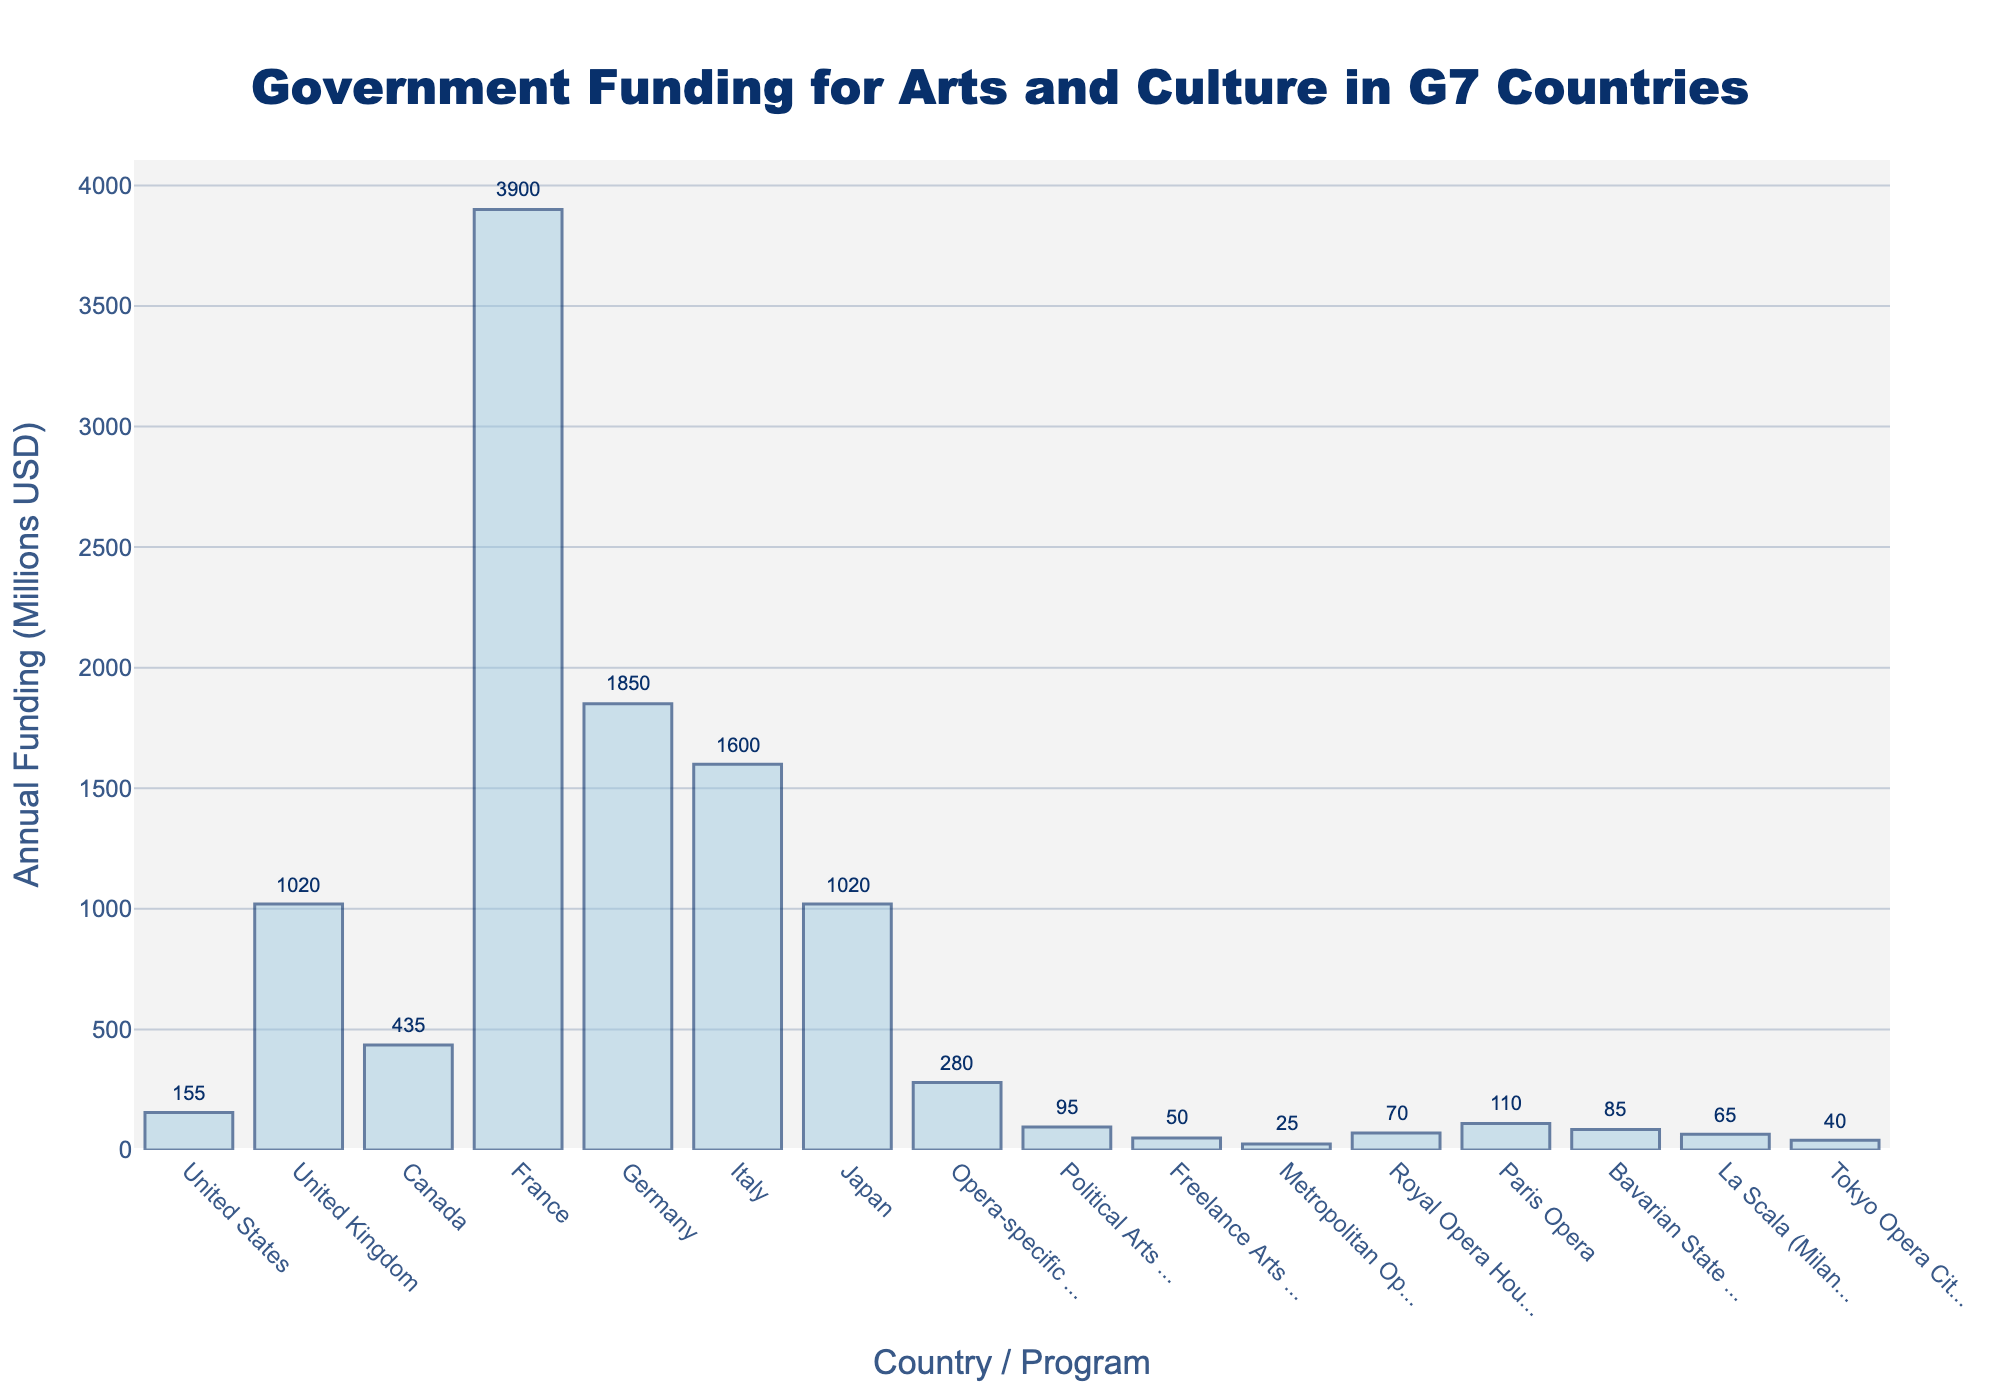What is the total annual funding for arts and culture in France and Germany? To get the total annual funding for France and Germany, sum the individual funding amounts for these two countries. France has $3900 million and Germany has $1850 million. So, the total is $3900 million + $1850 million = $5750 million.
Answer: $5750 million Which country has the highest annual arts funding? Look at the bars and identify the country with the tallest bar. France has the highest annual arts funding with $3900 million.
Answer: France How does the funding for opera-specific programs compare to the funding for the Paris Opera alone? Compare the height of the bars for 'Opera-specific Funding' and 'Paris Opera'. The 'Opera-specific Funding' is $280 million, whereas 'Paris Opera' is $110 million. The funding for opera-specific programs is higher by $280 million - $110 million = $170 million.
Answer: Opera-specific Funding is $170 million higher What is the combined annual funding for the United Kingdom and Italy? Sum the individual funding amounts for the United Kingdom ($1020 million) and Italy ($1600 million). The total combined funding is $1020 million + $1600 million = $2620 million.
Answer: $2620 million Which country has almost the exact same funding as Japan? Compare the bars and find the country with similar height to that of Japan, which has $1020 million in funding. The United Kingdom also has $1020 million in funding.
Answer: United Kingdom What is the difference in annual funding between Canada and the United States? Calculate the difference between the arts funding amounts for Canada ($435 million) and the United States ($155 million). The difference is $435 million - $155 million = $280 million.
Answer: $280 million How does funding for the Royal Opera House in London compare visually to the funding for Freelance Arts Initiatives? Compare the height of the bars for 'Royal Opera House (London)' and 'Freelance Arts Initiatives'. The bar for the Royal Opera House is higher. The Royal Opera House funding is $70 million, while Freelance Arts Initiatives is $50 million.
Answer: Royal Opera House funding is higher What is the average annual funding for the arts in the United States, Canada, and Japan? Sum the funding amounts for the United States ($155 million), Canada ($435 million), and Japan ($1020 million) and divide by the number of these countries. Total funding is $155 million + $435 million + $1020 million = $1610 million. The average funding is $1610 million / 3 = $536.67 million.
Answer: $536.67 million 